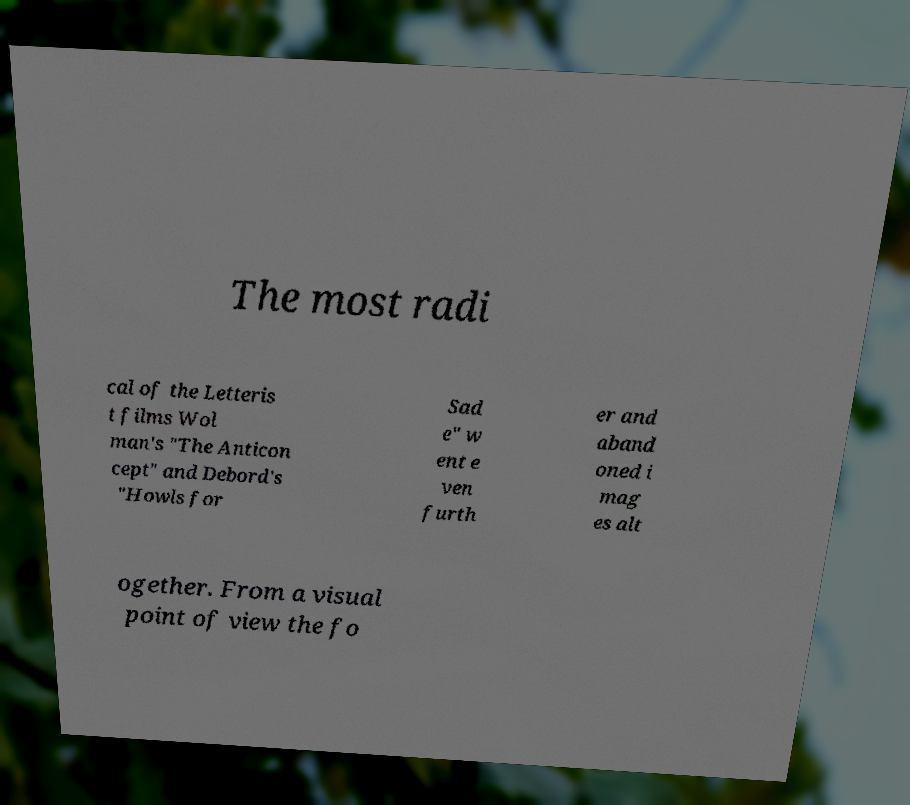Please read and relay the text visible in this image. What does it say? The most radi cal of the Letteris t films Wol man's "The Anticon cept" and Debord's "Howls for Sad e" w ent e ven furth er and aband oned i mag es alt ogether. From a visual point of view the fo 